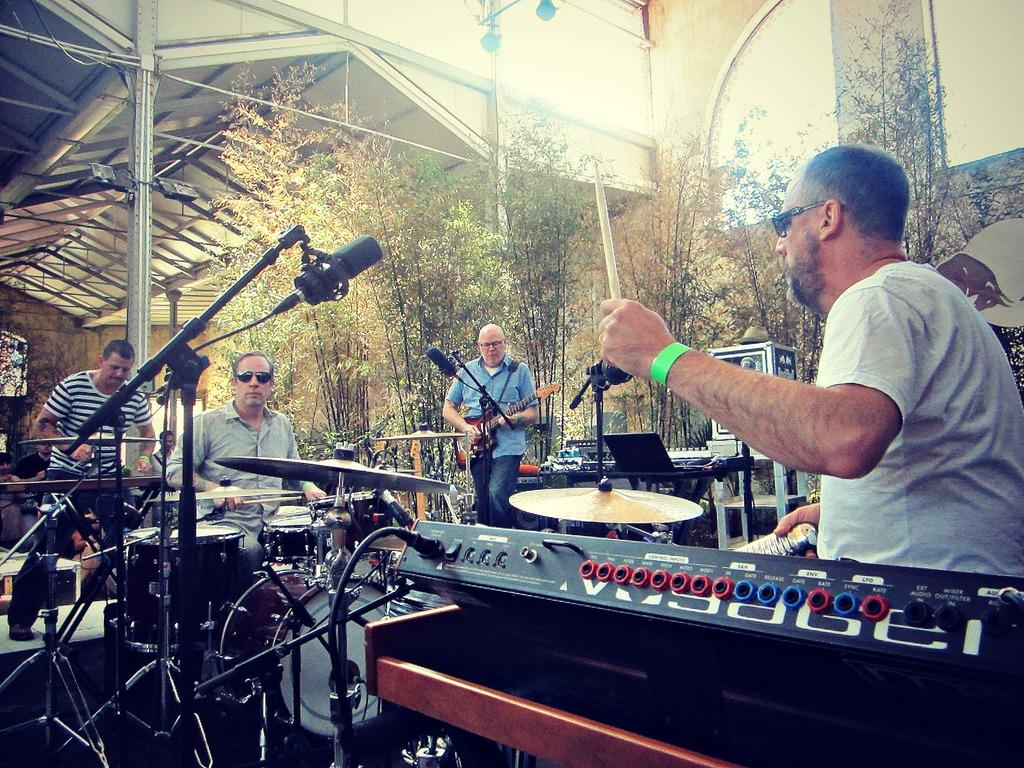What are the people on the stage doing? The people on the stage are performing by playing musical instruments. What can be seen near the performers on the stage? There is a microphone with a stand in the image. What is visible in the background of the image? There is a building, trees, and boxes in the background of the image. What type of faucet is installed in the room where the performance is taking place? There is no mention of a room or a faucet in the image, so it is not possible to answer that question. 